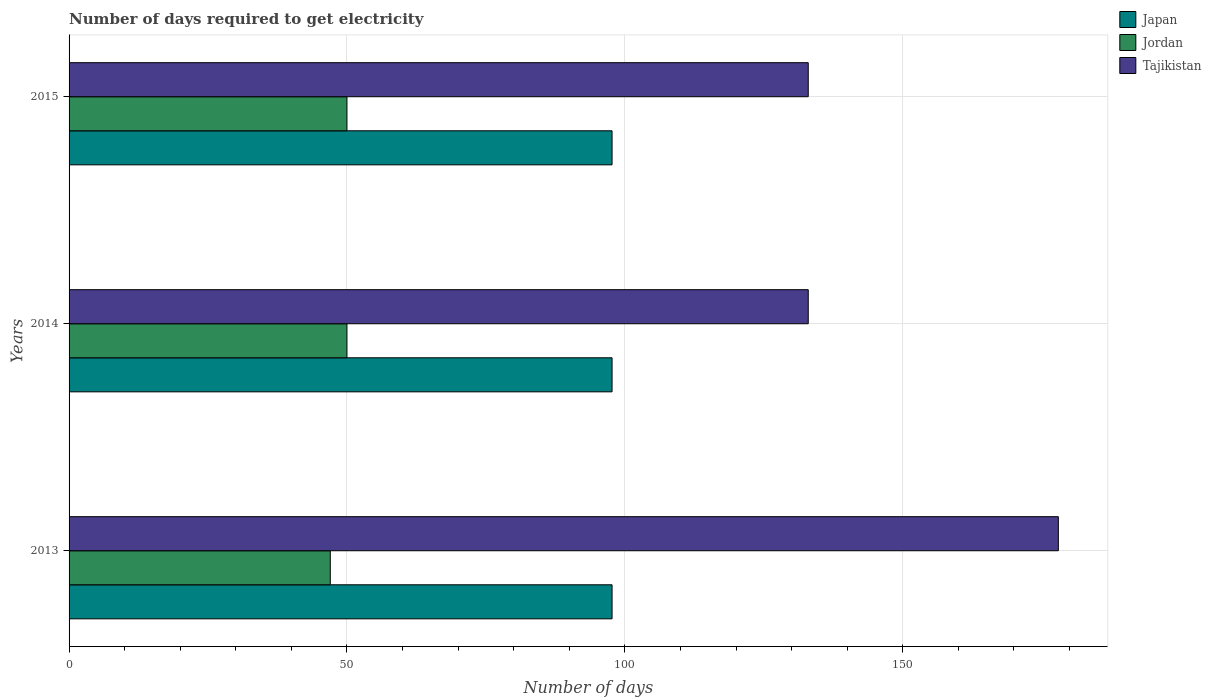Are the number of bars per tick equal to the number of legend labels?
Offer a terse response. Yes. How many bars are there on the 1st tick from the top?
Your response must be concise. 3. How many bars are there on the 2nd tick from the bottom?
Give a very brief answer. 3. In how many cases, is the number of bars for a given year not equal to the number of legend labels?
Make the answer very short. 0. What is the number of days required to get electricity in in Jordan in 2015?
Ensure brevity in your answer.  50. Across all years, what is the maximum number of days required to get electricity in in Jordan?
Make the answer very short. 50. Across all years, what is the minimum number of days required to get electricity in in Jordan?
Offer a terse response. 47. In which year was the number of days required to get electricity in in Jordan minimum?
Make the answer very short. 2013. What is the total number of days required to get electricity in in Japan in the graph?
Keep it short and to the point. 293.1. What is the difference between the number of days required to get electricity in in Jordan in 2013 and that in 2015?
Provide a short and direct response. -3. What is the difference between the number of days required to get electricity in in Jordan in 2014 and the number of days required to get electricity in in Tajikistan in 2013?
Provide a short and direct response. -128. What is the average number of days required to get electricity in in Jordan per year?
Your answer should be very brief. 49. In the year 2015, what is the difference between the number of days required to get electricity in in Japan and number of days required to get electricity in in Tajikistan?
Provide a succinct answer. -35.3. In how many years, is the number of days required to get electricity in in Jordan greater than 100 days?
Your answer should be very brief. 0. What is the ratio of the number of days required to get electricity in in Tajikistan in 2013 to that in 2015?
Your answer should be compact. 1.34. What is the difference between the highest and the second highest number of days required to get electricity in in Jordan?
Make the answer very short. 0. In how many years, is the number of days required to get electricity in in Jordan greater than the average number of days required to get electricity in in Jordan taken over all years?
Provide a short and direct response. 2. Is the sum of the number of days required to get electricity in in Tajikistan in 2014 and 2015 greater than the maximum number of days required to get electricity in in Jordan across all years?
Offer a very short reply. Yes. What does the 2nd bar from the top in 2013 represents?
Your answer should be very brief. Jordan. Is it the case that in every year, the sum of the number of days required to get electricity in in Jordan and number of days required to get electricity in in Tajikistan is greater than the number of days required to get electricity in in Japan?
Your response must be concise. Yes. Are all the bars in the graph horizontal?
Keep it short and to the point. Yes. How many years are there in the graph?
Provide a succinct answer. 3. What is the difference between two consecutive major ticks on the X-axis?
Offer a very short reply. 50. Are the values on the major ticks of X-axis written in scientific E-notation?
Provide a short and direct response. No. Does the graph contain any zero values?
Make the answer very short. No. Where does the legend appear in the graph?
Give a very brief answer. Top right. How are the legend labels stacked?
Make the answer very short. Vertical. What is the title of the graph?
Keep it short and to the point. Number of days required to get electricity. Does "Puerto Rico" appear as one of the legend labels in the graph?
Provide a succinct answer. No. What is the label or title of the X-axis?
Provide a succinct answer. Number of days. What is the Number of days in Japan in 2013?
Offer a terse response. 97.7. What is the Number of days in Tajikistan in 2013?
Make the answer very short. 178. What is the Number of days in Japan in 2014?
Give a very brief answer. 97.7. What is the Number of days in Jordan in 2014?
Ensure brevity in your answer.  50. What is the Number of days of Tajikistan in 2014?
Offer a very short reply. 133. What is the Number of days in Japan in 2015?
Offer a terse response. 97.7. What is the Number of days of Jordan in 2015?
Your response must be concise. 50. What is the Number of days in Tajikistan in 2015?
Give a very brief answer. 133. Across all years, what is the maximum Number of days of Japan?
Keep it short and to the point. 97.7. Across all years, what is the maximum Number of days in Jordan?
Your response must be concise. 50. Across all years, what is the maximum Number of days of Tajikistan?
Ensure brevity in your answer.  178. Across all years, what is the minimum Number of days in Japan?
Keep it short and to the point. 97.7. Across all years, what is the minimum Number of days in Jordan?
Offer a very short reply. 47. Across all years, what is the minimum Number of days in Tajikistan?
Offer a terse response. 133. What is the total Number of days of Japan in the graph?
Your answer should be compact. 293.1. What is the total Number of days in Jordan in the graph?
Offer a terse response. 147. What is the total Number of days in Tajikistan in the graph?
Offer a very short reply. 444. What is the difference between the Number of days of Japan in 2013 and that in 2014?
Make the answer very short. 0. What is the difference between the Number of days in Jordan in 2013 and that in 2014?
Make the answer very short. -3. What is the difference between the Number of days in Tajikistan in 2013 and that in 2014?
Your response must be concise. 45. What is the difference between the Number of days of Japan in 2013 and that in 2015?
Your answer should be very brief. 0. What is the difference between the Number of days of Jordan in 2013 and that in 2015?
Provide a succinct answer. -3. What is the difference between the Number of days in Japan in 2014 and that in 2015?
Ensure brevity in your answer.  0. What is the difference between the Number of days of Jordan in 2014 and that in 2015?
Provide a short and direct response. 0. What is the difference between the Number of days in Tajikistan in 2014 and that in 2015?
Give a very brief answer. 0. What is the difference between the Number of days of Japan in 2013 and the Number of days of Jordan in 2014?
Keep it short and to the point. 47.7. What is the difference between the Number of days of Japan in 2013 and the Number of days of Tajikistan in 2014?
Make the answer very short. -35.3. What is the difference between the Number of days of Jordan in 2013 and the Number of days of Tajikistan in 2014?
Your response must be concise. -86. What is the difference between the Number of days of Japan in 2013 and the Number of days of Jordan in 2015?
Keep it short and to the point. 47.7. What is the difference between the Number of days of Japan in 2013 and the Number of days of Tajikistan in 2015?
Offer a very short reply. -35.3. What is the difference between the Number of days of Jordan in 2013 and the Number of days of Tajikistan in 2015?
Your answer should be very brief. -86. What is the difference between the Number of days of Japan in 2014 and the Number of days of Jordan in 2015?
Offer a terse response. 47.7. What is the difference between the Number of days in Japan in 2014 and the Number of days in Tajikistan in 2015?
Offer a very short reply. -35.3. What is the difference between the Number of days of Jordan in 2014 and the Number of days of Tajikistan in 2015?
Your answer should be compact. -83. What is the average Number of days in Japan per year?
Ensure brevity in your answer.  97.7. What is the average Number of days of Tajikistan per year?
Your answer should be compact. 148. In the year 2013, what is the difference between the Number of days of Japan and Number of days of Jordan?
Provide a succinct answer. 50.7. In the year 2013, what is the difference between the Number of days in Japan and Number of days in Tajikistan?
Offer a terse response. -80.3. In the year 2013, what is the difference between the Number of days of Jordan and Number of days of Tajikistan?
Offer a very short reply. -131. In the year 2014, what is the difference between the Number of days of Japan and Number of days of Jordan?
Ensure brevity in your answer.  47.7. In the year 2014, what is the difference between the Number of days in Japan and Number of days in Tajikistan?
Make the answer very short. -35.3. In the year 2014, what is the difference between the Number of days in Jordan and Number of days in Tajikistan?
Provide a short and direct response. -83. In the year 2015, what is the difference between the Number of days in Japan and Number of days in Jordan?
Keep it short and to the point. 47.7. In the year 2015, what is the difference between the Number of days in Japan and Number of days in Tajikistan?
Your answer should be compact. -35.3. In the year 2015, what is the difference between the Number of days of Jordan and Number of days of Tajikistan?
Give a very brief answer. -83. What is the ratio of the Number of days in Japan in 2013 to that in 2014?
Make the answer very short. 1. What is the ratio of the Number of days in Jordan in 2013 to that in 2014?
Give a very brief answer. 0.94. What is the ratio of the Number of days in Tajikistan in 2013 to that in 2014?
Offer a terse response. 1.34. What is the ratio of the Number of days in Tajikistan in 2013 to that in 2015?
Offer a very short reply. 1.34. What is the ratio of the Number of days of Jordan in 2014 to that in 2015?
Offer a terse response. 1. What is the ratio of the Number of days in Tajikistan in 2014 to that in 2015?
Give a very brief answer. 1. What is the difference between the highest and the second highest Number of days in Japan?
Your answer should be compact. 0. What is the difference between the highest and the second highest Number of days of Jordan?
Offer a very short reply. 0. What is the difference between the highest and the second highest Number of days in Tajikistan?
Your answer should be very brief. 45. What is the difference between the highest and the lowest Number of days in Jordan?
Make the answer very short. 3. 